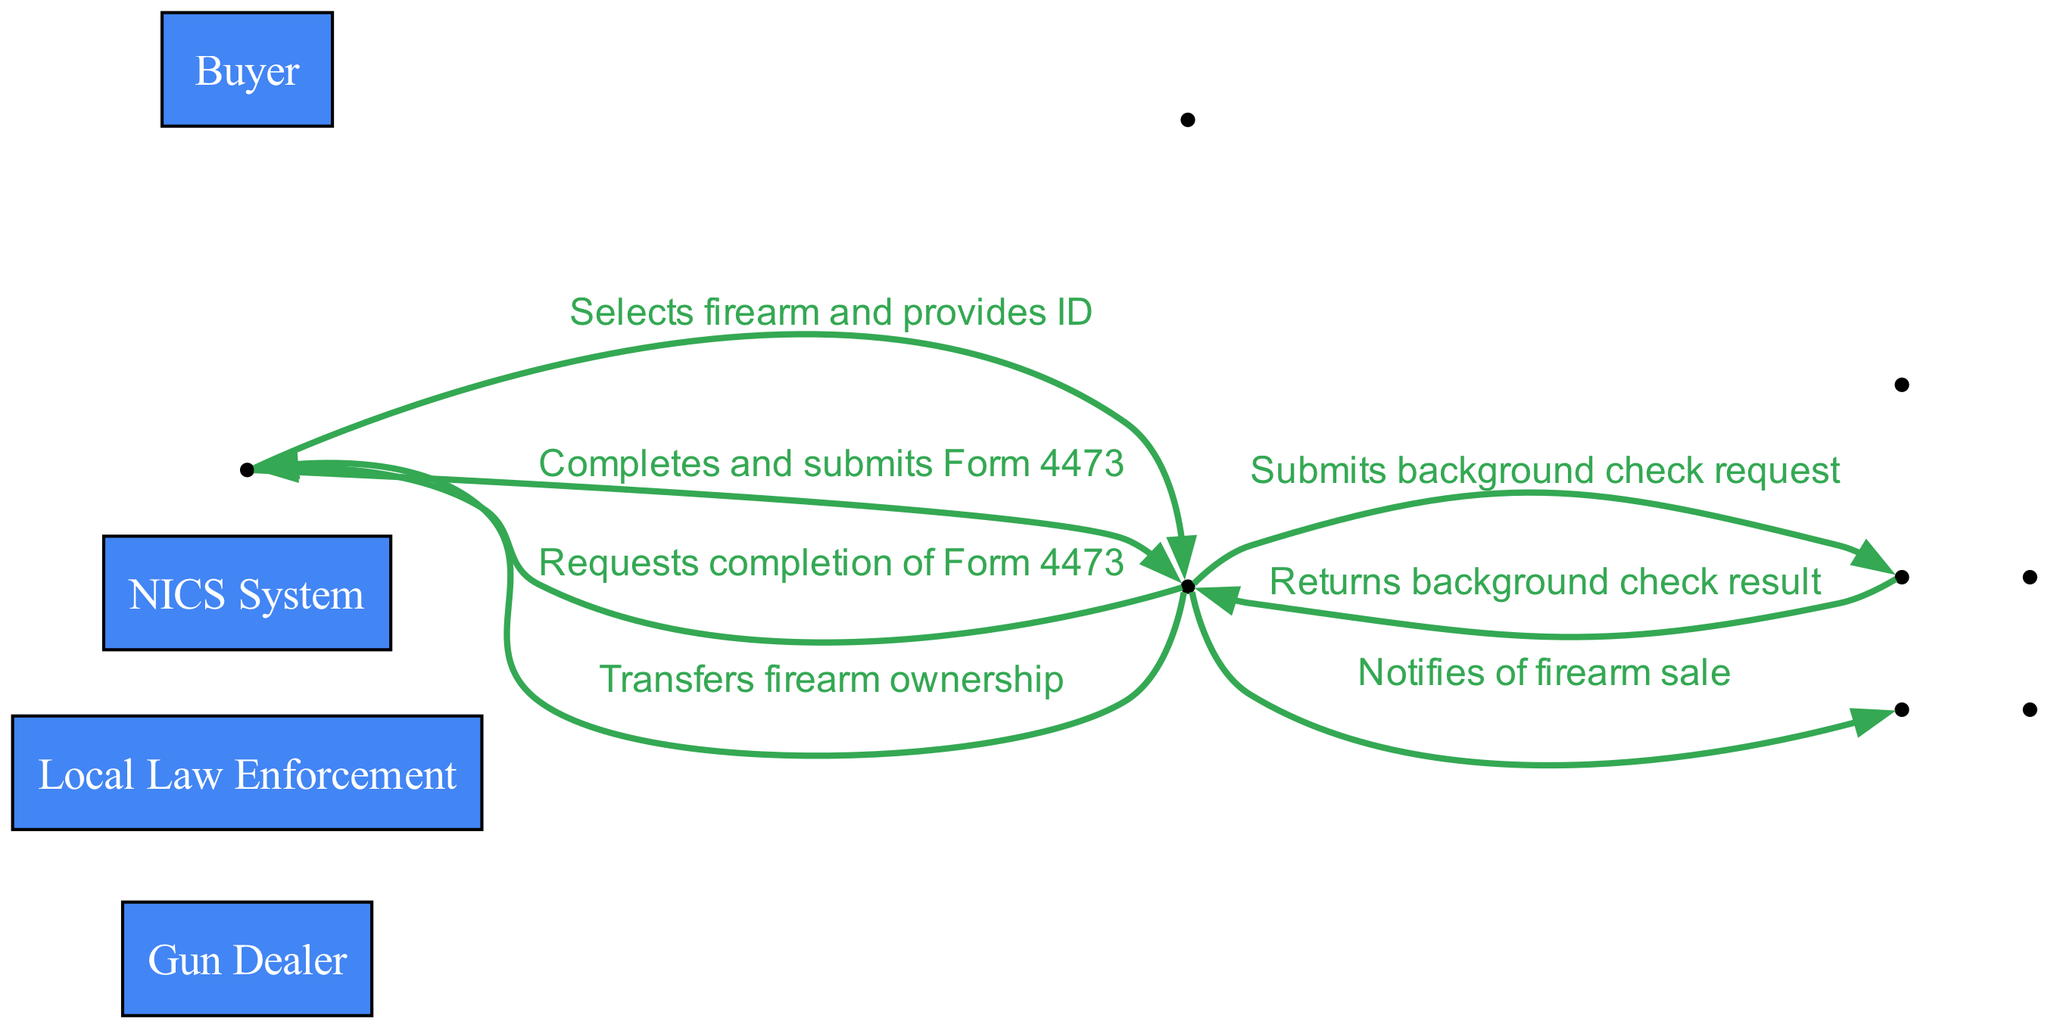What is the first action taken by the buyer? The first action performed by the buyer according to the sequence diagram is selecting a firearm and providing their ID to the gun dealer. This is indicated as the initial step in the sequence that begins with the buyer's interaction.
Answer: Selects firearm and provides ID How many actors are involved in the process? The diagram presents four distinct actors: Buyer, Gun Dealer, NICS System, and Local Law Enforcement, each of them participating in the sequence of actions related to firearm purchase.
Answer: 4 What action follows the background check request from the gun dealer? After the gun dealer submits the background check request to the NICS System, the next step is that the NICS System returns the background check result back to the gun dealer, as illustrated in the sequence.
Answer: Returns background check result What form must the buyer complete after the background check? Following the background check result, the buyer is required to complete and submit Form 4473, as indicated in the sequence that outlines their responsibilities in the process of legally purchasing a firearm.
Answer: Form 4473 Which actor does the gun dealer notify about the firearm sale? According to the sequence diagram, the gun dealer notifies the Local Law Enforcement about the firearm sale, which is an essential step in keeping law enforcement informed about transactions involving firearms.
Answer: Local Law Enforcement What is the final action in the sequence for the buyer? The last action in the sequence for the buyer is the transfer of firearm ownership, which indicates the completion of the firearm purchase process after all prior steps have been successfully fulfilled.
Answer: Transfers firearm ownership What happens immediately after the buyer submits Form 4473? Immediately after the buyer submits Form 4473, the gun dealer notifies the Local Law Enforcement of the firearm sale, which is part of the sequence demonstrating the necessary communication to ensure legality and awareness of the transaction.
Answer: Notifies of firearm sale Which actor performs the action of submitting the background check request? The gun dealer is responsible for submitting the background check request to the NICS System, as outlined in the sequence of actions where the gun dealer initiates the legal verification process.
Answer: Gun Dealer 